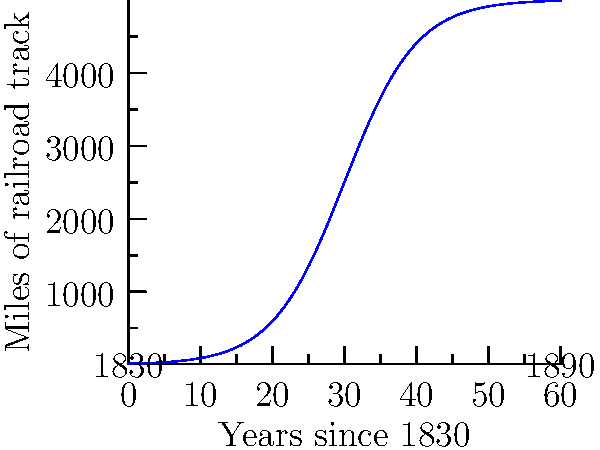The graph shows the growth of railroad track mileage in the United States from 1830 to 1890. At what point in time was the rate of railroad construction the highest, and what was the approximate rate of construction at that time in miles per year? To solve this problem, we need to follow these steps:

1) The rate of change is represented by the slope of the curve. The steepest point on the curve indicates the highest rate of change.

2) Visually, the curve appears to be steepest around the midpoint of the x-axis, which corresponds to about 30 years after 1830, or around 1860.

3) The given function for the curve is:

   $$f(x) = \frac{5000}{1+e^{-0.2(x-30)}}$$

4) To find the exact point of maximum growth rate, we need to find the second derivative and set it to zero. However, this is beyond the scope of this question.

5) We can approximate the rate of change at this point by calculating the slope of the tangent line. The derivative of the logistic function at its midpoint (x = 30) is:

   $$f'(30) = \frac{5000 \cdot 0.2}{4} = 250$$

6) This means that around 1860, the rate of railroad construction was approximately 250 miles per year.
Answer: 1860; 250 miles per year 